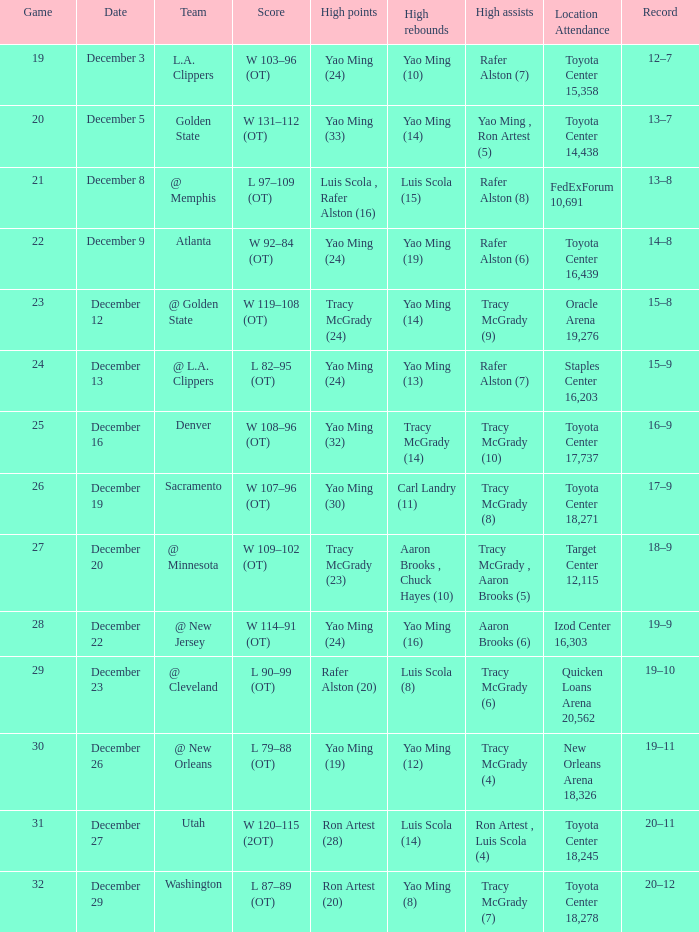When @ new orleans is the group with the most rebounds? Yao Ming (12). 